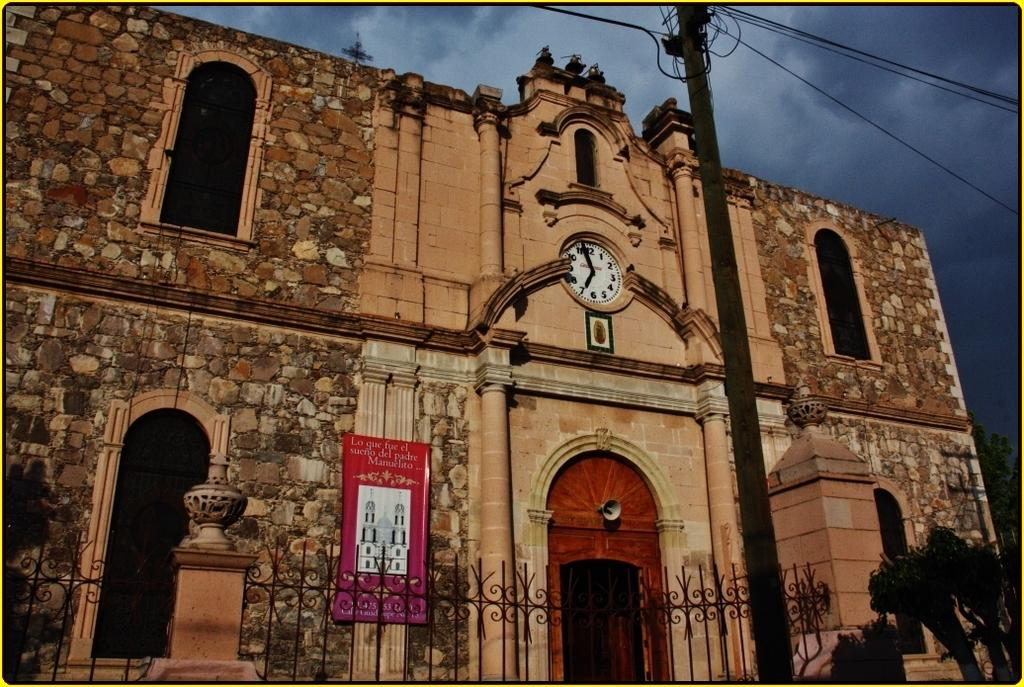<image>
Share a concise interpretation of the image provided. A church sits beneath a stormy sky with a red banner that reads "Lo que fue el sueno" 